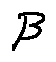<formula> <loc_0><loc_0><loc_500><loc_500>\beta</formula> 